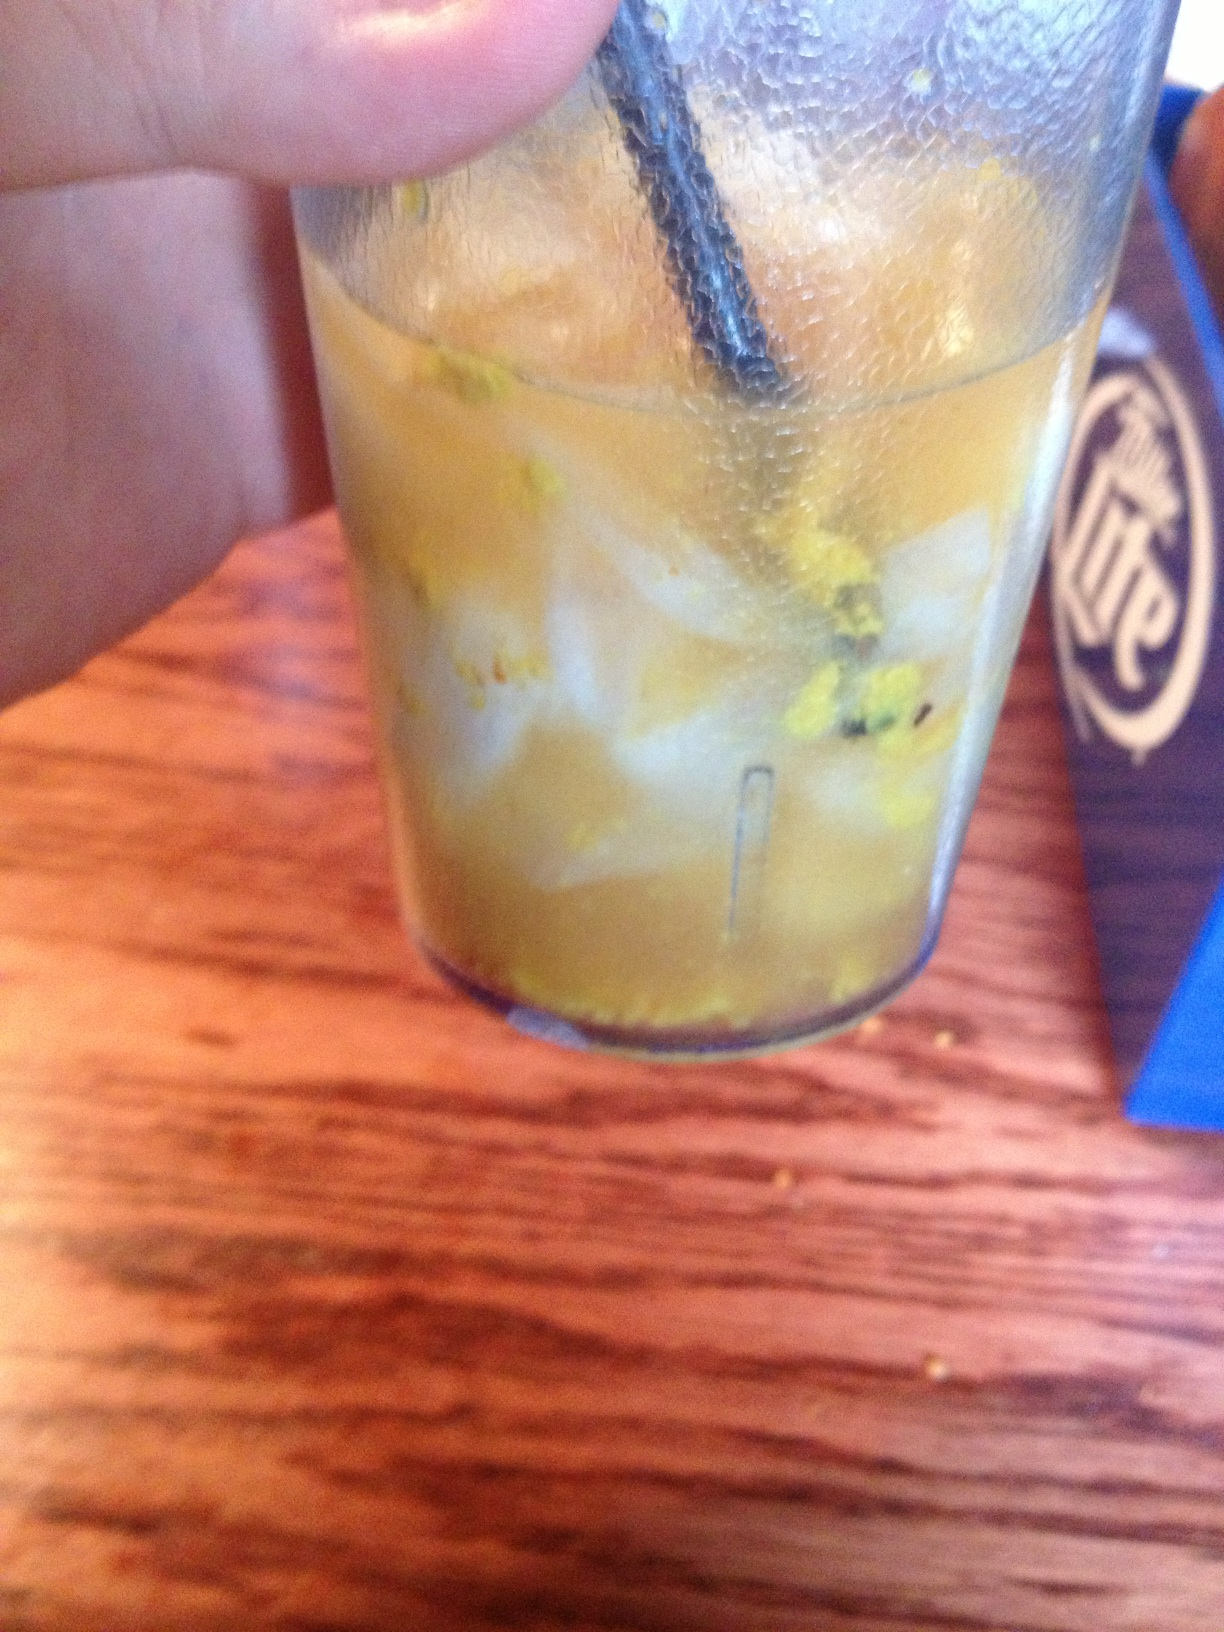I can't identify this drink. Any ideas? This drink looks a bit unusual, with what appears to be some kind of grated zest or small particles. It could be a variation of a fruit-based cocktail or a mocktail with added garnishes. Checking with the restaurant staff would provide you with a definite answer. Do such drinks with unusual particles have a specific name? There's no one specific name for drinks with unusual particles, as they can vary widely. They might be called infused drinks, experimental cocktails, or simply garnished beverages, depending on the ingredients and preparation methods used. Could this be a drink meant for an adventurous palate? Absolutely! Restaurants often create specialty drinks intended to offer a new experience or to match certain adventurous palettes. Such drinks may combine uncommon ingredients or presentation methods to intrigue and delight customers who enjoy trying new things. 